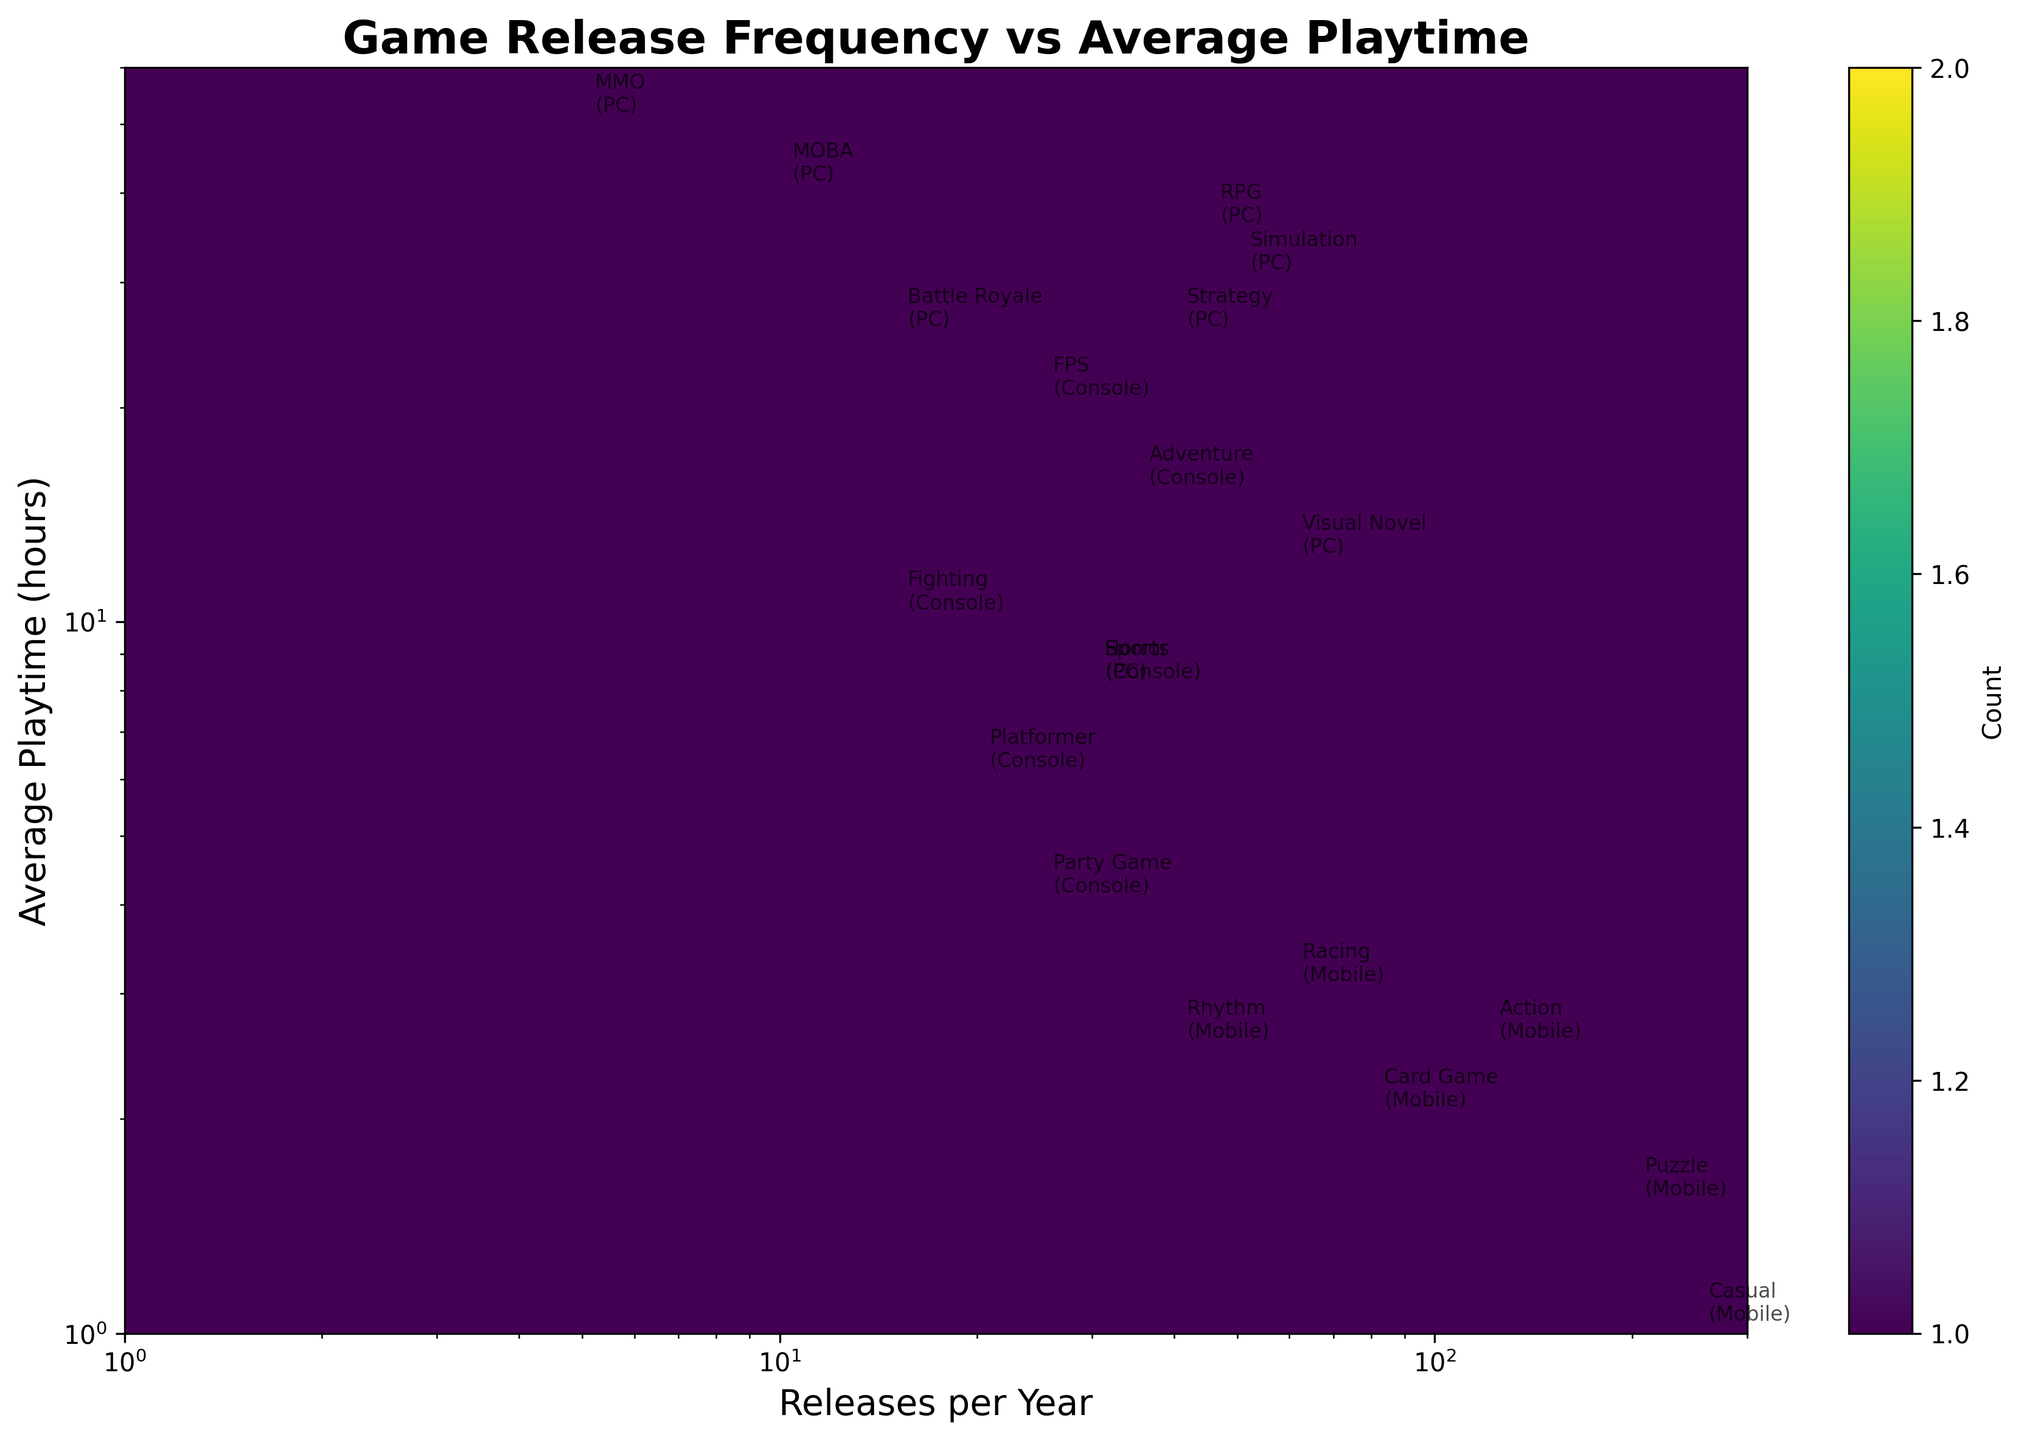What's the title of the hexbin plot? The title is shown at the top of the plot. It is clearly displayed in a bold font.
Answer: Game Release Frequency vs Average Playtime What are the ranges of the x-axis and y-axis? The x-axis and y-axis ranges can be determined by looking at the axis ticks. The x-axis ranges from 1 to 300, and the y-axis ranges from 1 to 60, both in a logarithmic scale.
Answer: x-axis: 1 to 300, y-axis: 1 to 60 Which genre on the PC platform has the highest playtime? To find this, identify the point with the highest y-coordinate labeled as 'PC'. MMO on PC has the highest average playtime of 50 hours.
Answer: MMO What can you infer about genres with high release frequency on mobile? Observe the points labeled 'Mobile' towards the high values of the x-axis. Genres associated with mobile platforms like Casual and Puzzle have very high release frequencies but relatively low average playtimes.
Answer: High release frequency, low average playtime Which platform has the most genres with an average playtime over 20 hours? Check the annotations for each platform where the y-coordinate (average playtime) exceeds 20 hours. PC has Strategy, MOBA, Battle Royale, and MMO genres with average playtimes over 20 hours.
Answer: PC What is the approximate count of data points in the densest hexbin? The color bar indicates the count, and the darkest hex denotes the highest density. The plot shows a color that corresponds to the higher count on the color bar for 'Mobile' games around 40 releases per year and 2 hours of playtime.
Answer: Dense hex area has multiple points, but exact count can be inferred visually from color, approximately 3-5 points Which genre and platform combination has the fewest game releases per year? Locate the annotation with the lowest x-coordinate value. MMO on PC has the fewest releases per year, which is 5.
Answer: MMO on PC Compare the average playtime and release frequency for RPG and FPS genres; which has a higher average playtime? Identify the points for RPG (PC) and FPS (Console) and compare their y-coordinates (average playtime). RPG has a playtime of 35 hours, while FPS has 20 hours.
Answer: RPG How does the game release frequency for Strategy on PC compare to Racing on Mobile? Identify the annotations for Strategy (PC) and Racing (Mobile) and compare their x-coordinates (release frequency). Strategy on PC has 40 releases per year, and Racing on Mobile has 60.
Answer: Racing on Mobile is higher 